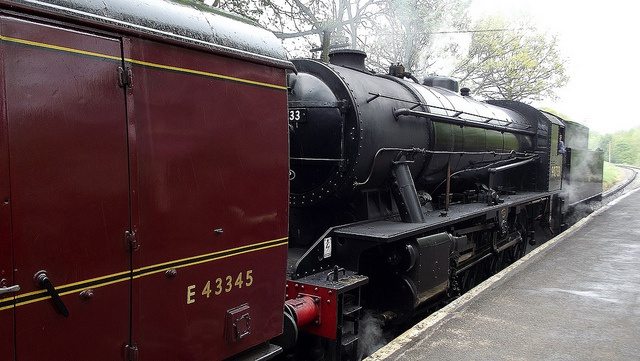Describe the objects in this image and their specific colors. I can see train in black, purple, maroon, gray, and darkgray tones and people in purple, gray, darkgray, and black tones in this image. 